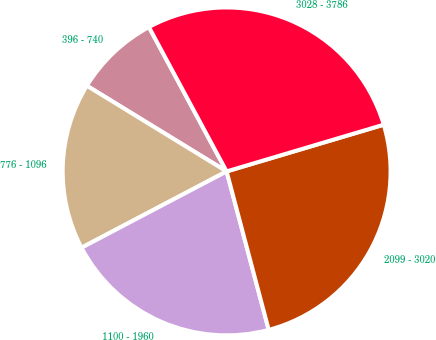<chart> <loc_0><loc_0><loc_500><loc_500><pie_chart><fcel>396 - 740<fcel>776 - 1096<fcel>1100 - 1960<fcel>2099 - 3020<fcel>3028 - 3786<nl><fcel>8.39%<fcel>16.46%<fcel>21.43%<fcel>25.47%<fcel>28.26%<nl></chart> 